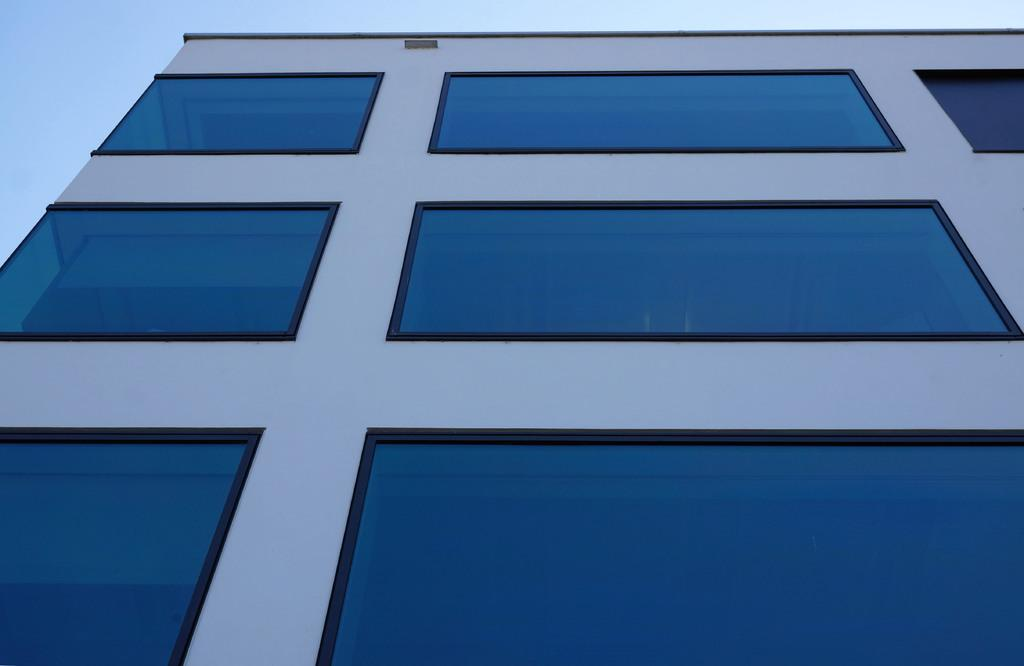What is the main structure visible in the image? There is a building in the image. What feature of the building stands out? The building has blue color glass windows. What type of poisonous plant can be seen growing near the building in the image? There is no poisonous plant visible in the image; the provided facts only mention the building and its blue color glass windows. 